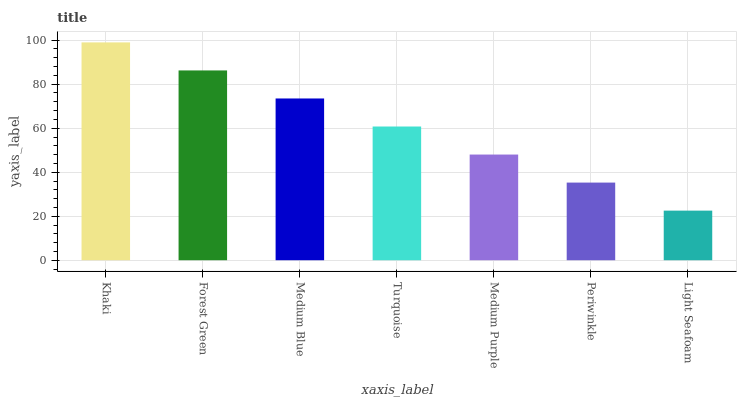Is Light Seafoam the minimum?
Answer yes or no. Yes. Is Khaki the maximum?
Answer yes or no. Yes. Is Forest Green the minimum?
Answer yes or no. No. Is Forest Green the maximum?
Answer yes or no. No. Is Khaki greater than Forest Green?
Answer yes or no. Yes. Is Forest Green less than Khaki?
Answer yes or no. Yes. Is Forest Green greater than Khaki?
Answer yes or no. No. Is Khaki less than Forest Green?
Answer yes or no. No. Is Turquoise the high median?
Answer yes or no. Yes. Is Turquoise the low median?
Answer yes or no. Yes. Is Light Seafoam the high median?
Answer yes or no. No. Is Khaki the low median?
Answer yes or no. No. 